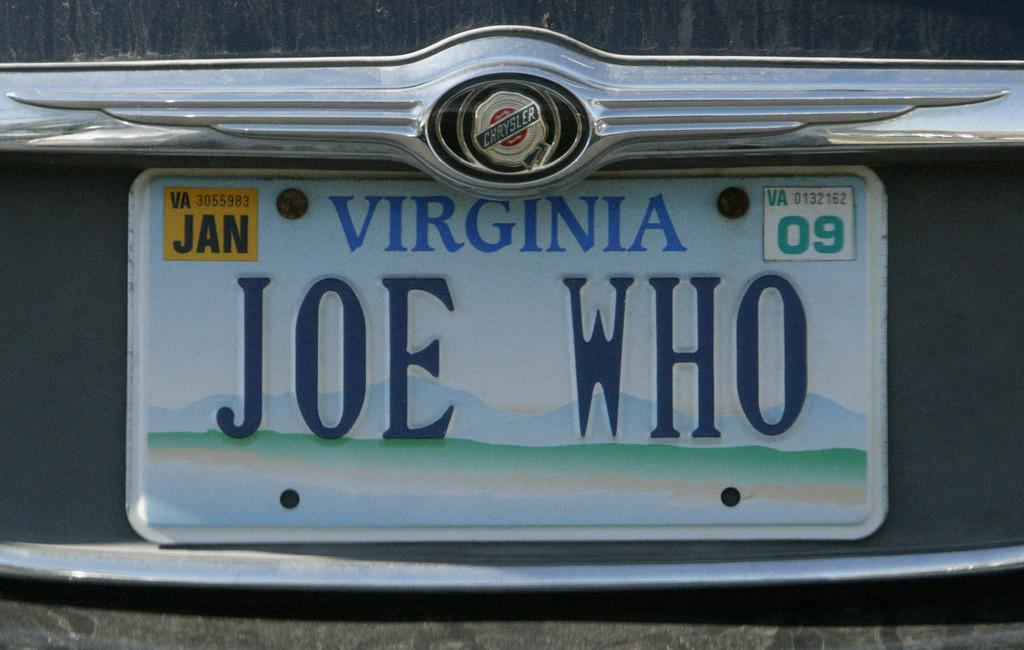<image>
Provide a brief description of the given image. White Virginia license plate which says Joe Who on it. 